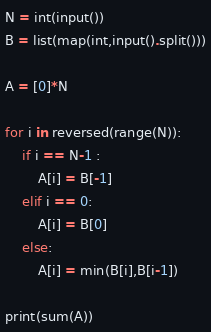Convert code to text. <code><loc_0><loc_0><loc_500><loc_500><_Python_>N = int(input())
B = list(map(int,input().split()))

A = [0]*N

for i in reversed(range(N)):
    if i == N-1 :
        A[i] = B[-1]
    elif i == 0:
        A[i] = B[0]
    else:
        A[i] = min(B[i],B[i-1])

print(sum(A))</code> 